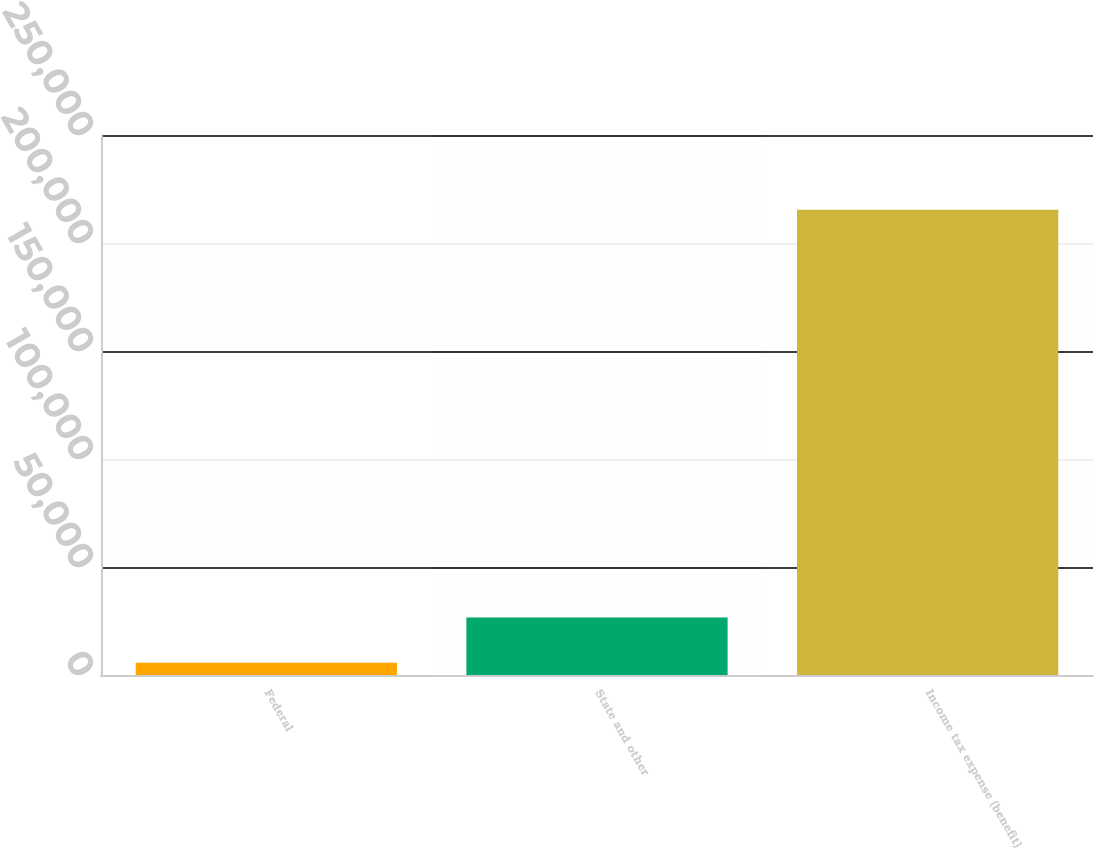Convert chart to OTSL. <chart><loc_0><loc_0><loc_500><loc_500><bar_chart><fcel>Federal<fcel>State and other<fcel>Income tax expense (benefit)<nl><fcel>5619<fcel>26599.1<fcel>215420<nl></chart> 